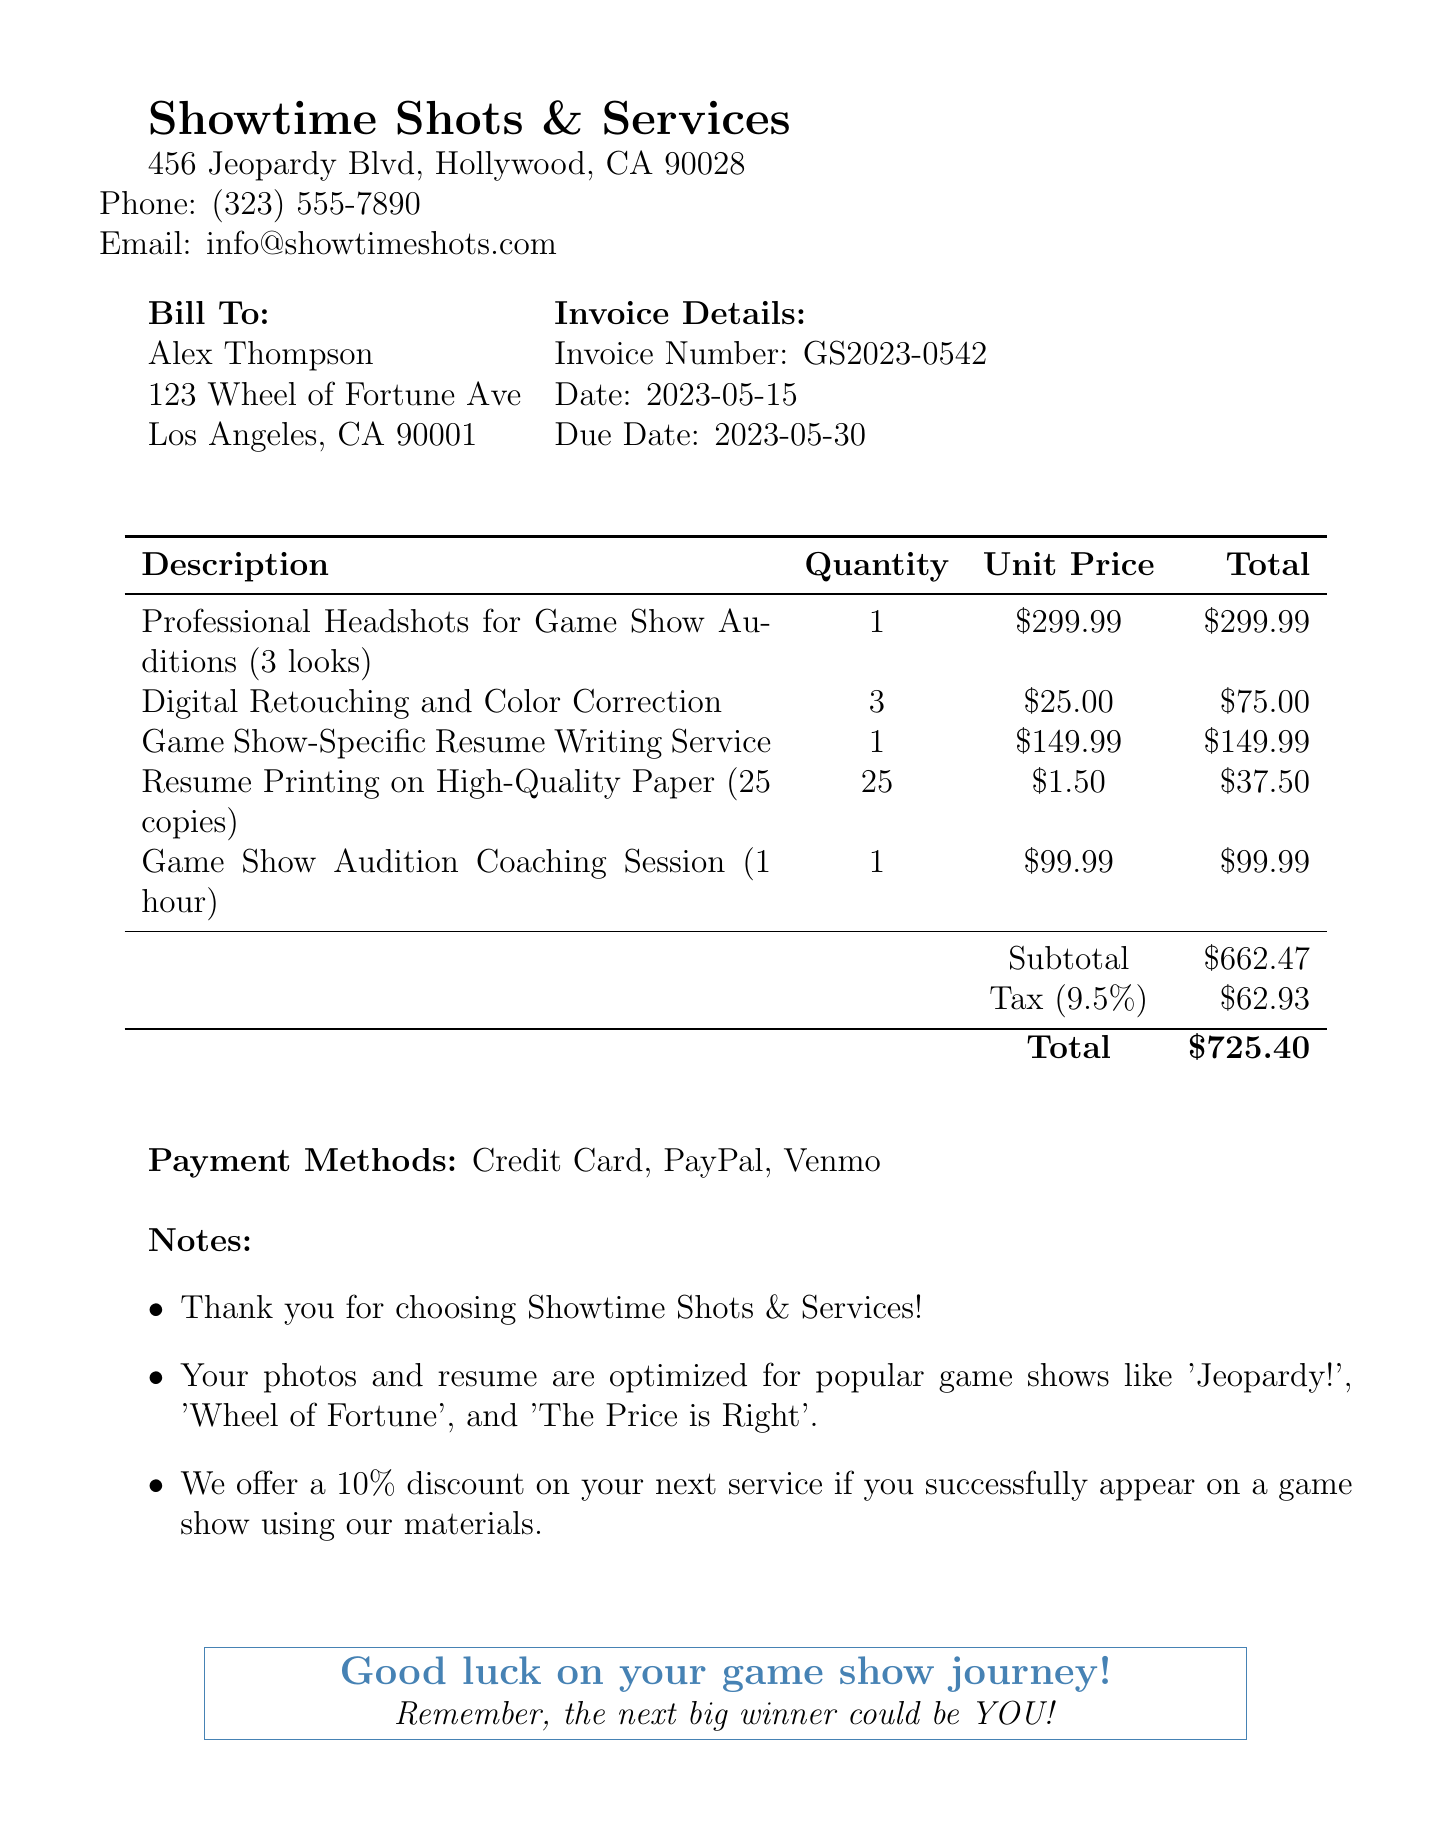What is the invoice number? The invoice number is mentioned at the top of the document for identification, which is GS2023-0542.
Answer: GS2023-0542 Who is the client? The client's name is stated at the beginning of the invoice under the "Bill To" section, which is Alex Thompson.
Answer: Alex Thompson What is the due date for the invoice? The due date is listed in the invoice details section, which is 2023-05-30.
Answer: 2023-05-30 How many copies of the resume were printed? The quantity of the resume copies printed is specified in the items list, which states 25 copies.
Answer: 25 What is the total amount due? The total amount due is provided after adding the subtotal and tax, which is $725.40.
Answer: $725.40 How many items are listed in the invoice? The invoice includes five items in the itemized list.
Answer: 5 What discount is offered for the next service? A specific discount for future services is given in the notes section, which is 10%.
Answer: 10% What type of service is mentioned for game show auditions? The services tailored for game show auditions are outlined in the items, including professional headshots and resume writing.
Answer: Professional Headshots What payment methods are accepted? The accepted payment methods are clearly listed, which include Credit Card, PayPal, and Venmo.
Answer: Credit Card, PayPal, Venmo 